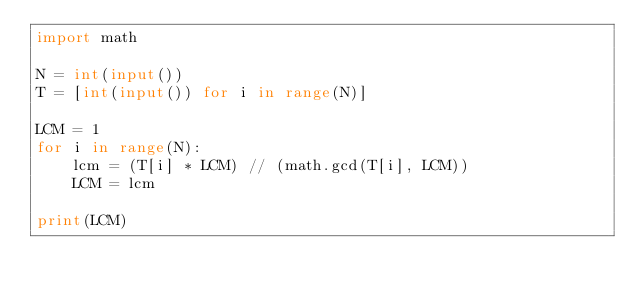Convert code to text. <code><loc_0><loc_0><loc_500><loc_500><_Python_>import math

N = int(input())
T = [int(input()) for i in range(N)]

LCM = 1
for i in range(N):
    lcm = (T[i] * LCM) // (math.gcd(T[i], LCM))
    LCM = lcm

print(LCM)
</code> 